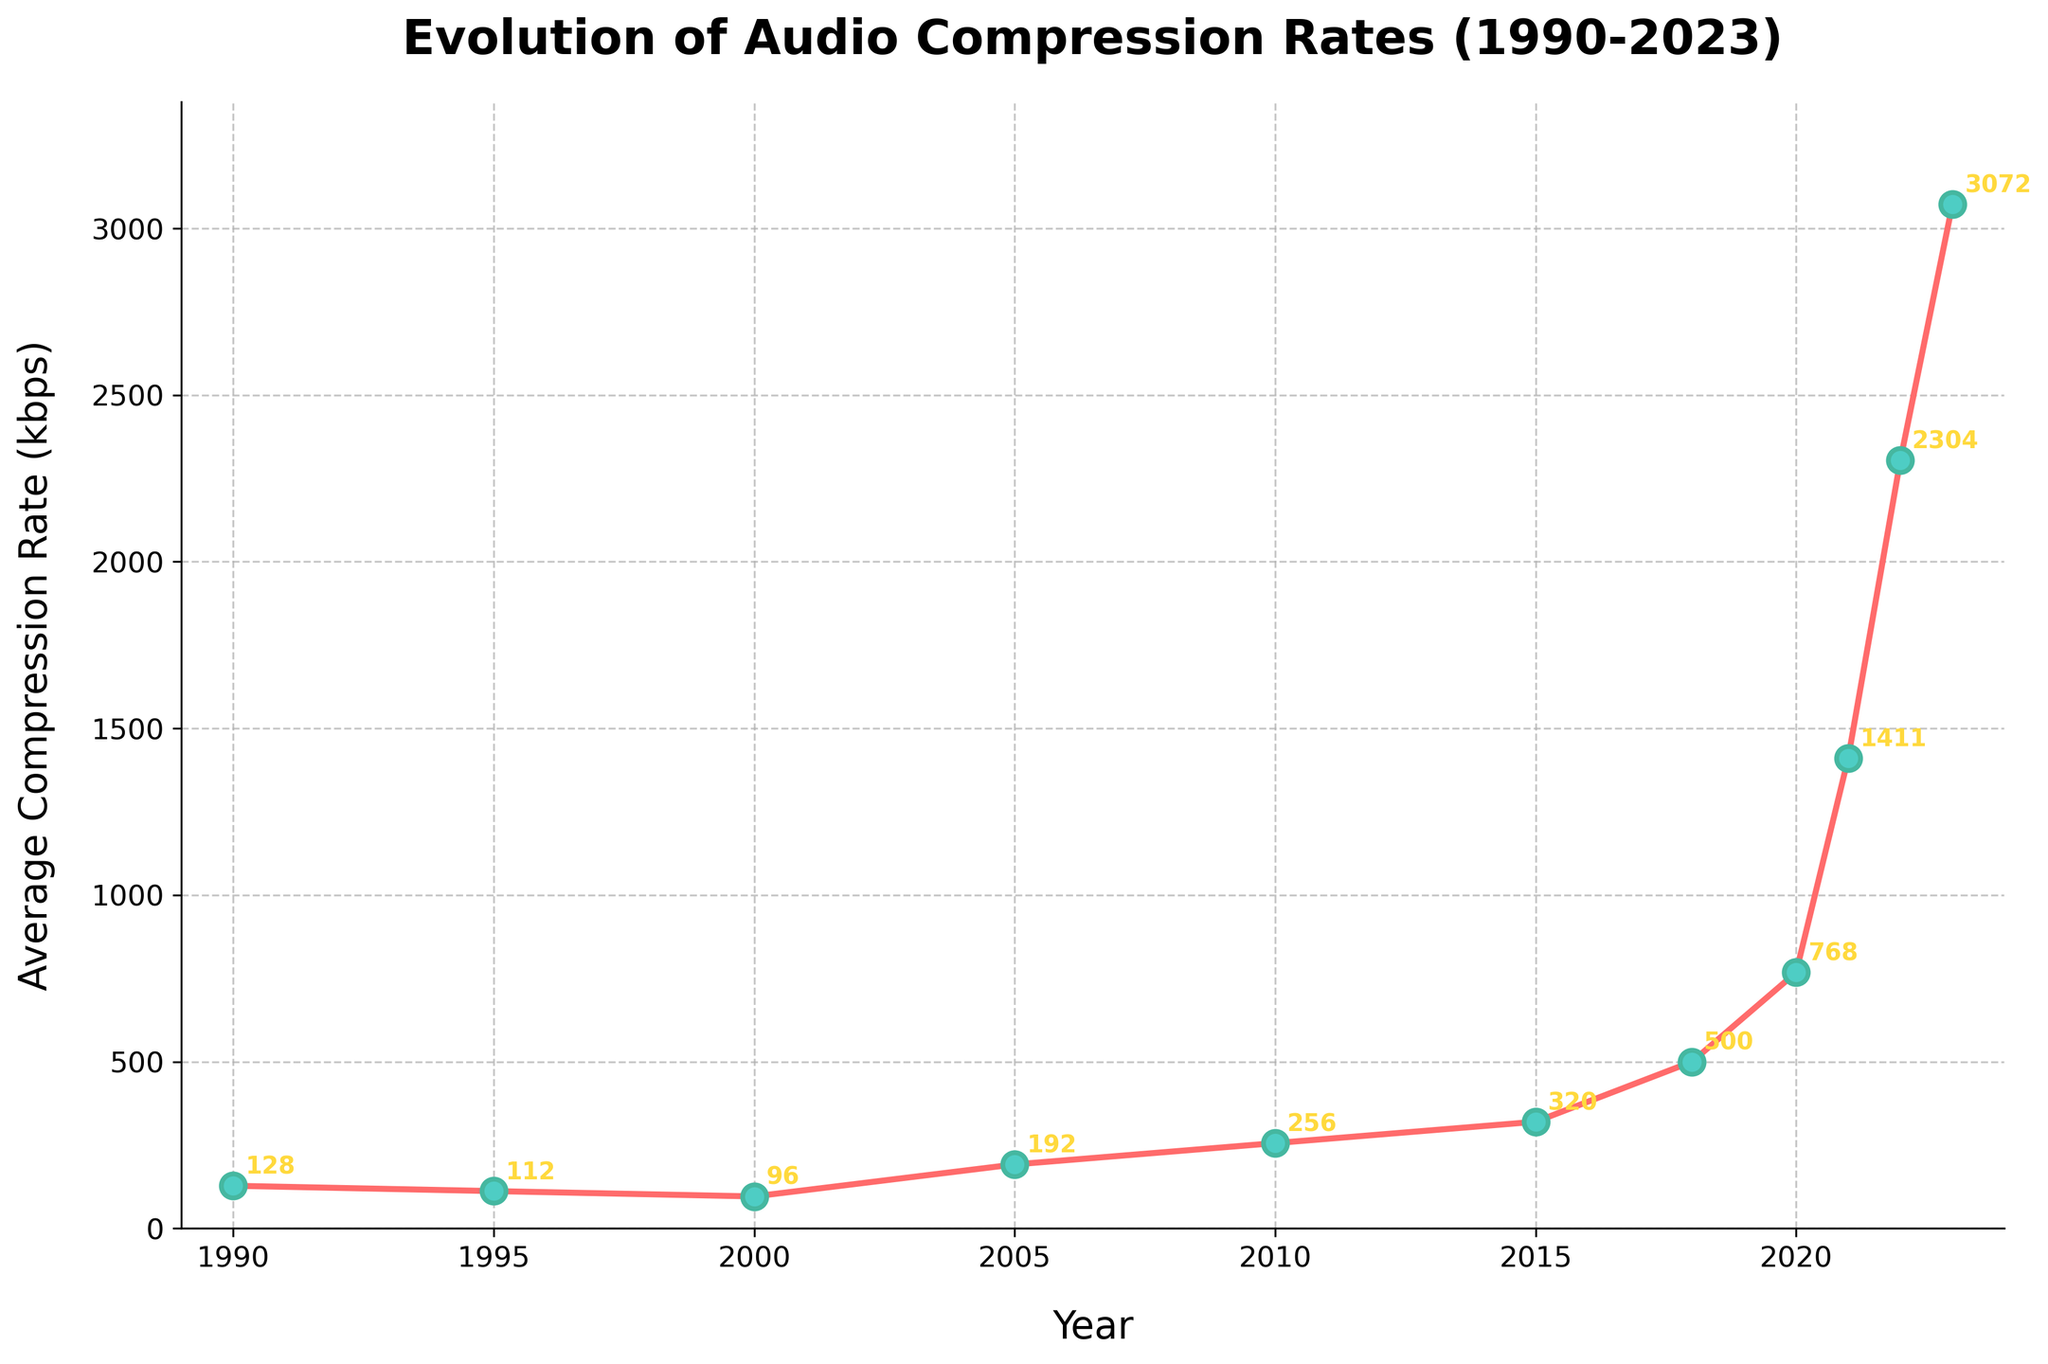What was the average compression rate in 2010? Look at the x-axis for the year 2010 and check the corresponding value on the y-axis, which is 256 kbps
Answer: 256 kbps When did the average compression rate first exceed 500 kbps? Identify the first year in which the average compression rate exceeds 500 kbps by analyzing the plotted points. This happens in 2020
Answer: 2020 What's the difference in the average compression rate between 1995 and 2000? Note the values for 1995 and 2000 which are 112 kbps and 96 kbps respectively. The difference is \(112 - 96 = 16 \) kbps
Answer: 16 kbps Which year had the smallest increase in the average compression rate compared to the previous year? Compare the differences between each consecutive year's average compression rate and identify the smallest increase. The smallest is between 1995 and 2000 with a decrease of \(112 - 96 = 16\) kbps
Answer: 1995 to 2000 Which year had the highest average compression rate, and what was the rate? Find the highest point on the y-axis and note the corresponding year and value. The highest rate is in 2023 at 3072 kbps
Answer: 2023, 3072 kbps By how much did the average compression rate increase from 2018 to 2021? Note the values for 2018 and 2021 which are 500 kbps and 1411 kbps respectively. The increase is \(1411 - 500 = 911\) kbps
Answer: 911 kbps Which period saw the most significant increase in the average compression rate? Compare the rate of change between each consecutive pair of years. The largest increase occurred between 2021 (1411 kbps) and 2022 (2304 kbps) with an increase of \(2304 - 1411 = 893 \) kbps
Answer: 2021 to 2022 What is the average compression rate for the first decade (1990-2000)? Sum the rates for 1990, 1995, and 2000 and divide by the number of data points. \((128 + 112 + 96) / 3 = 112 \) kbps
Answer: 112 kbps Describe the trend in the average compression rate from 1990 to 2005 Observe the changes in the plotted points from 1990 (128 kbps) to 2005 (192 kbps). There is a decrease until 2000 followed by an increase up to 2005
Answer: Decrease then increase Is there a year where the average compression rate equals 320 kbps? Identify the plotted points and see if any year matches the 320 kbps value on the y-axis. The year is 2015
Answer: 2015 